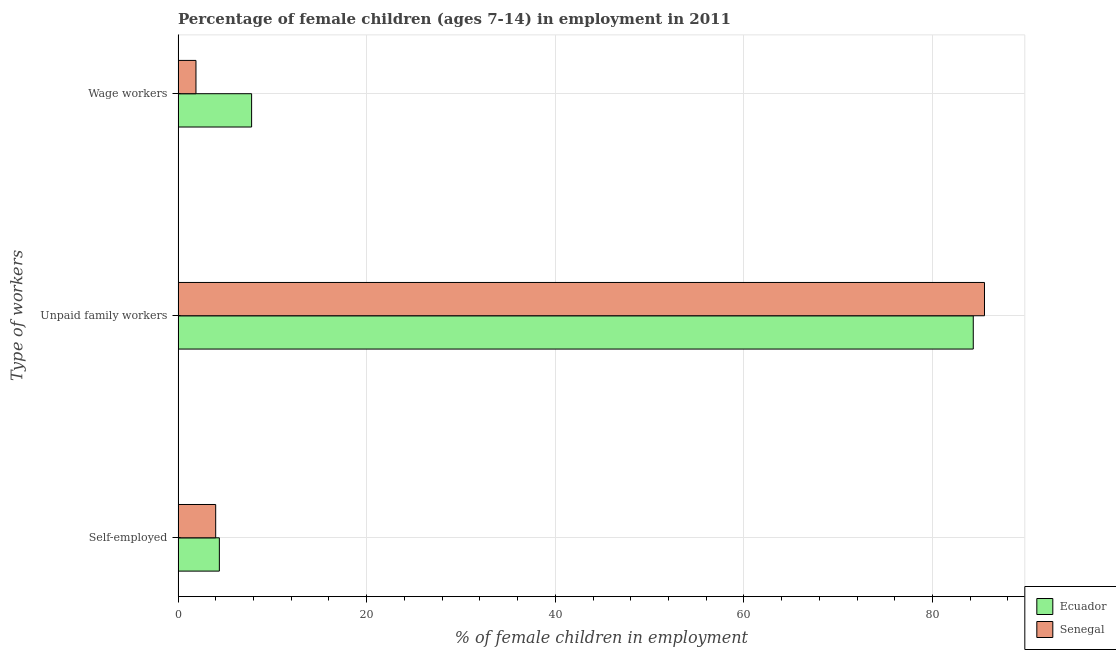Are the number of bars on each tick of the Y-axis equal?
Offer a very short reply. Yes. How many bars are there on the 1st tick from the top?
Make the answer very short. 2. What is the label of the 2nd group of bars from the top?
Provide a short and direct response. Unpaid family workers. Across all countries, what is the maximum percentage of children employed as unpaid family workers?
Your response must be concise. 85.51. Across all countries, what is the minimum percentage of self employed children?
Offer a very short reply. 3.99. In which country was the percentage of self employed children maximum?
Your answer should be very brief. Ecuador. In which country was the percentage of children employed as wage workers minimum?
Provide a succinct answer. Senegal. What is the total percentage of self employed children in the graph?
Offer a terse response. 8.37. What is the difference between the percentage of children employed as unpaid family workers in Ecuador and that in Senegal?
Your answer should be very brief. -1.19. What is the difference between the percentage of self employed children in Ecuador and the percentage of children employed as unpaid family workers in Senegal?
Ensure brevity in your answer.  -81.13. What is the average percentage of children employed as unpaid family workers per country?
Make the answer very short. 84.91. What is the difference between the percentage of children employed as wage workers and percentage of self employed children in Senegal?
Give a very brief answer. -2.09. In how many countries, is the percentage of children employed as wage workers greater than 84 %?
Provide a succinct answer. 0. What is the ratio of the percentage of children employed as unpaid family workers in Senegal to that in Ecuador?
Your answer should be compact. 1.01. What is the difference between the highest and the lowest percentage of children employed as wage workers?
Your answer should be very brief. 5.9. In how many countries, is the percentage of children employed as unpaid family workers greater than the average percentage of children employed as unpaid family workers taken over all countries?
Ensure brevity in your answer.  1. Is the sum of the percentage of children employed as unpaid family workers in Ecuador and Senegal greater than the maximum percentage of self employed children across all countries?
Provide a short and direct response. Yes. What does the 2nd bar from the top in Unpaid family workers represents?
Make the answer very short. Ecuador. What does the 2nd bar from the bottom in Self-employed represents?
Keep it short and to the point. Senegal. Is it the case that in every country, the sum of the percentage of self employed children and percentage of children employed as unpaid family workers is greater than the percentage of children employed as wage workers?
Offer a terse response. Yes. What is the title of the graph?
Your answer should be very brief. Percentage of female children (ages 7-14) in employment in 2011. What is the label or title of the X-axis?
Your response must be concise. % of female children in employment. What is the label or title of the Y-axis?
Offer a terse response. Type of workers. What is the % of female children in employment in Ecuador in Self-employed?
Give a very brief answer. 4.38. What is the % of female children in employment of Senegal in Self-employed?
Offer a very short reply. 3.99. What is the % of female children in employment of Ecuador in Unpaid family workers?
Give a very brief answer. 84.32. What is the % of female children in employment in Senegal in Unpaid family workers?
Your response must be concise. 85.51. Across all Type of workers, what is the maximum % of female children in employment in Ecuador?
Provide a short and direct response. 84.32. Across all Type of workers, what is the maximum % of female children in employment of Senegal?
Offer a very short reply. 85.51. Across all Type of workers, what is the minimum % of female children in employment of Ecuador?
Offer a very short reply. 4.38. Across all Type of workers, what is the minimum % of female children in employment in Senegal?
Keep it short and to the point. 1.9. What is the total % of female children in employment of Ecuador in the graph?
Offer a very short reply. 96.5. What is the total % of female children in employment in Senegal in the graph?
Your answer should be very brief. 91.4. What is the difference between the % of female children in employment of Ecuador in Self-employed and that in Unpaid family workers?
Provide a succinct answer. -79.94. What is the difference between the % of female children in employment of Senegal in Self-employed and that in Unpaid family workers?
Give a very brief answer. -81.52. What is the difference between the % of female children in employment of Ecuador in Self-employed and that in Wage workers?
Offer a terse response. -3.42. What is the difference between the % of female children in employment in Senegal in Self-employed and that in Wage workers?
Ensure brevity in your answer.  2.09. What is the difference between the % of female children in employment in Ecuador in Unpaid family workers and that in Wage workers?
Your response must be concise. 76.52. What is the difference between the % of female children in employment in Senegal in Unpaid family workers and that in Wage workers?
Make the answer very short. 83.61. What is the difference between the % of female children in employment of Ecuador in Self-employed and the % of female children in employment of Senegal in Unpaid family workers?
Keep it short and to the point. -81.13. What is the difference between the % of female children in employment in Ecuador in Self-employed and the % of female children in employment in Senegal in Wage workers?
Your answer should be very brief. 2.48. What is the difference between the % of female children in employment of Ecuador in Unpaid family workers and the % of female children in employment of Senegal in Wage workers?
Provide a short and direct response. 82.42. What is the average % of female children in employment of Ecuador per Type of workers?
Keep it short and to the point. 32.17. What is the average % of female children in employment in Senegal per Type of workers?
Make the answer very short. 30.47. What is the difference between the % of female children in employment in Ecuador and % of female children in employment in Senegal in Self-employed?
Offer a terse response. 0.39. What is the difference between the % of female children in employment in Ecuador and % of female children in employment in Senegal in Unpaid family workers?
Provide a short and direct response. -1.19. What is the ratio of the % of female children in employment in Ecuador in Self-employed to that in Unpaid family workers?
Offer a terse response. 0.05. What is the ratio of the % of female children in employment in Senegal in Self-employed to that in Unpaid family workers?
Your answer should be very brief. 0.05. What is the ratio of the % of female children in employment in Ecuador in Self-employed to that in Wage workers?
Your answer should be very brief. 0.56. What is the ratio of the % of female children in employment in Senegal in Self-employed to that in Wage workers?
Make the answer very short. 2.1. What is the ratio of the % of female children in employment of Ecuador in Unpaid family workers to that in Wage workers?
Your answer should be very brief. 10.81. What is the ratio of the % of female children in employment of Senegal in Unpaid family workers to that in Wage workers?
Provide a short and direct response. 45.01. What is the difference between the highest and the second highest % of female children in employment of Ecuador?
Provide a succinct answer. 76.52. What is the difference between the highest and the second highest % of female children in employment of Senegal?
Keep it short and to the point. 81.52. What is the difference between the highest and the lowest % of female children in employment in Ecuador?
Provide a short and direct response. 79.94. What is the difference between the highest and the lowest % of female children in employment in Senegal?
Your answer should be compact. 83.61. 